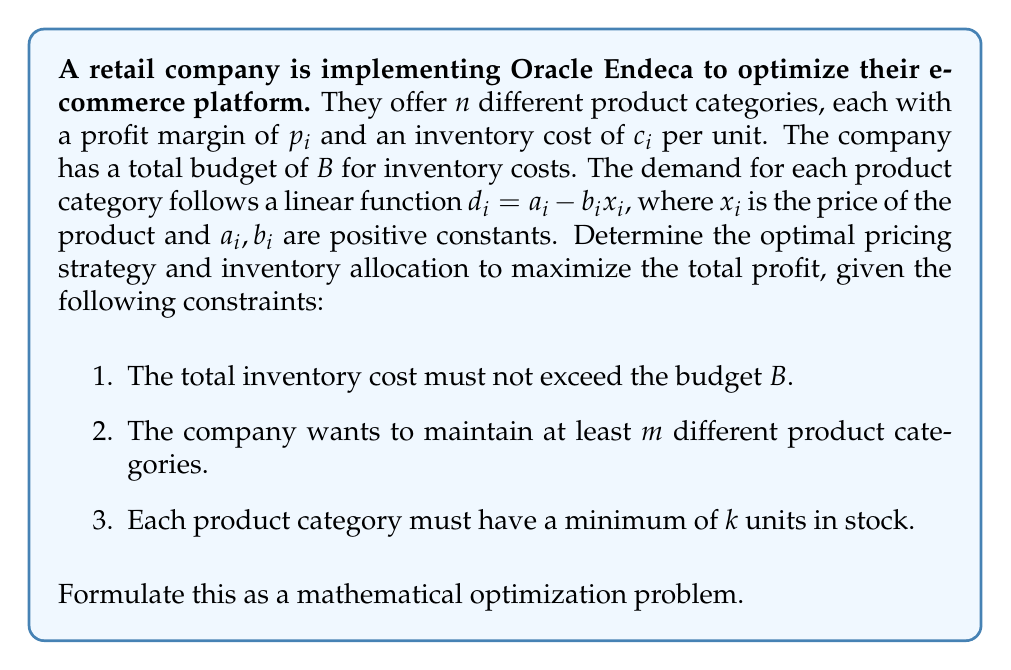Can you solve this math problem? To formulate this optimization problem, we need to define our decision variables, objective function, and constraints:

1. Decision variables:
   $x_i$: Price of product category $i$
   $q_i$: Quantity of product category $i$ to stock
   $y_i$: Binary variable (1 if product category $i$ is offered, 0 otherwise)

2. Objective function:
   We want to maximize the total profit, which is the sum of profits from each product category:
   
   $$\text{Maximize } \sum_{i=1}^n (p_i x_i - c_i) q_i$$

3. Constraints:
   a) Budget constraint:
      $$\sum_{i=1}^n c_i q_i \leq B$$
   
   b) Minimum number of product categories:
      $$\sum_{i=1}^n y_i \geq m$$
   
   c) Minimum stock for each offered category:
      $$q_i \geq k y_i \quad \forall i = 1, \ldots, n$$
   
   d) Demand constraint:
      $$q_i \leq a_i - b_i x_i \quad \forall i = 1, \ldots, n$$
   
   e) Binary constraint:
      $$y_i \in \{0, 1\} \quad \forall i = 1, \ldots, n$$
   
   f) Non-negativity constraints:
      $$x_i, q_i \geq 0 \quad \forall i = 1, \ldots, n$$

The complete mathematical optimization problem can be formulated as:

$$
\begin{aligned}
\text{Maximize } & \sum_{i=1}^n (p_i x_i - c_i) q_i \\
\text{subject to: } & \sum_{i=1}^n c_i q_i \leq B \\
& \sum_{i=1}^n y_i \geq m \\
& q_i \geq k y_i \quad \forall i = 1, \ldots, n \\
& q_i \leq a_i - b_i x_i \quad \forall i = 1, \ldots, n \\
& y_i \in \{0, 1\} \quad \forall i = 1, \ldots, n \\
& x_i, q_i \geq 0 \quad \forall i = 1, \ldots, n
\end{aligned}
$$

This formulation captures the key aspects of the problem, including the trade-off between product variety and inventory costs, while maximizing profit. The solution to this optimization problem will provide the optimal pricing strategy ($x_i$) and inventory allocation ($q_i$) for each product category, as well as which categories to offer ($y_i$).
Answer: The mathematical optimization problem is formulated as:

$$
\begin{aligned}
\text{Maximize } & \sum_{i=1}^n (p_i x_i - c_i) q_i \\
\text{subject to: } & \sum_{i=1}^n c_i q_i \leq B \\
& \sum_{i=1}^n y_i \geq m \\
& q_i \geq k y_i \quad \forall i = 1, \ldots, n \\
& q_i \leq a_i - b_i x_i \quad \forall i = 1, \ldots, n \\
& y_i \in \{0, 1\} \quad \forall i = 1, \ldots, n \\
& x_i, q_i \geq 0 \quad \forall i = 1, \ldots, n
\end{aligned}
$$ 